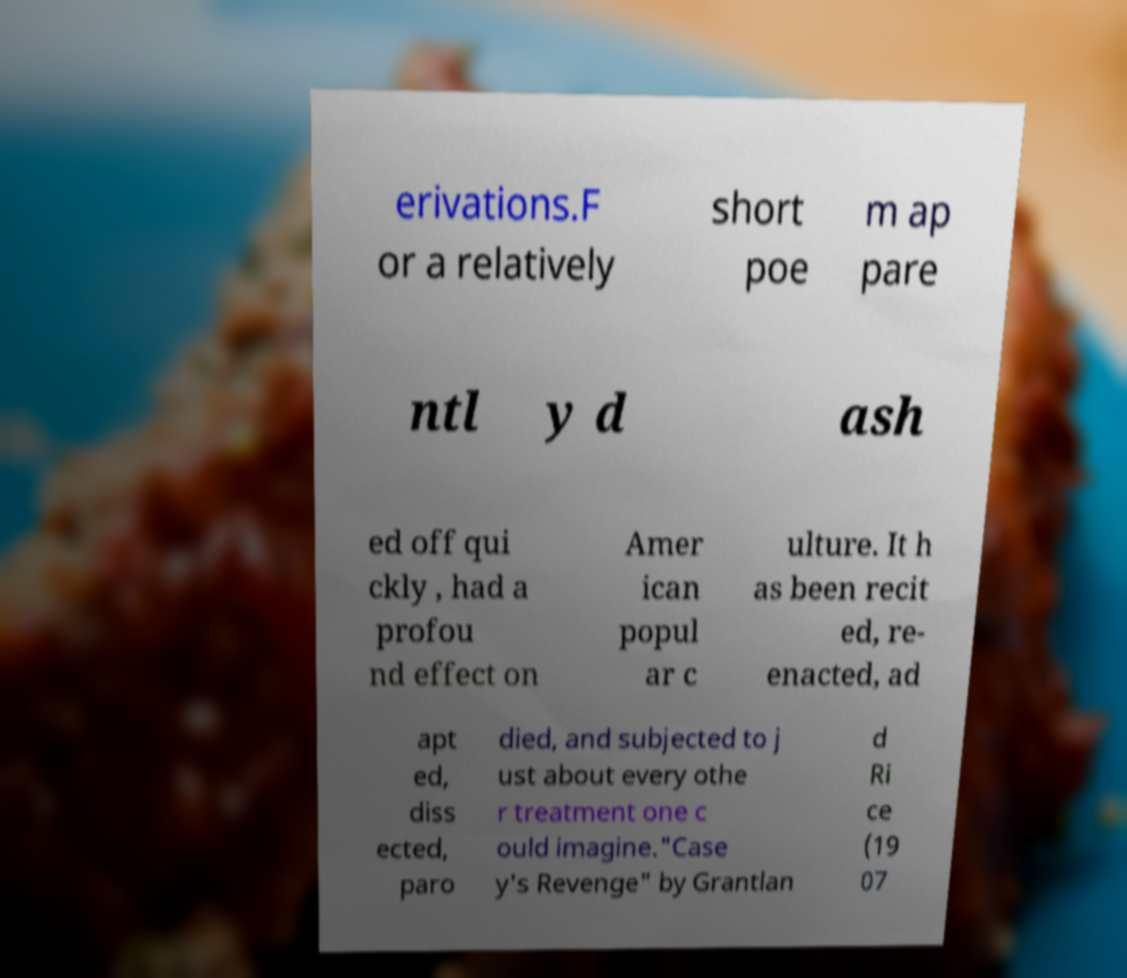Can you read and provide the text displayed in the image?This photo seems to have some interesting text. Can you extract and type it out for me? erivations.F or a relatively short poe m ap pare ntl y d ash ed off qui ckly , had a profou nd effect on Amer ican popul ar c ulture. It h as been recit ed, re- enacted, ad apt ed, diss ected, paro died, and subjected to j ust about every othe r treatment one c ould imagine."Case y's Revenge" by Grantlan d Ri ce (19 07 